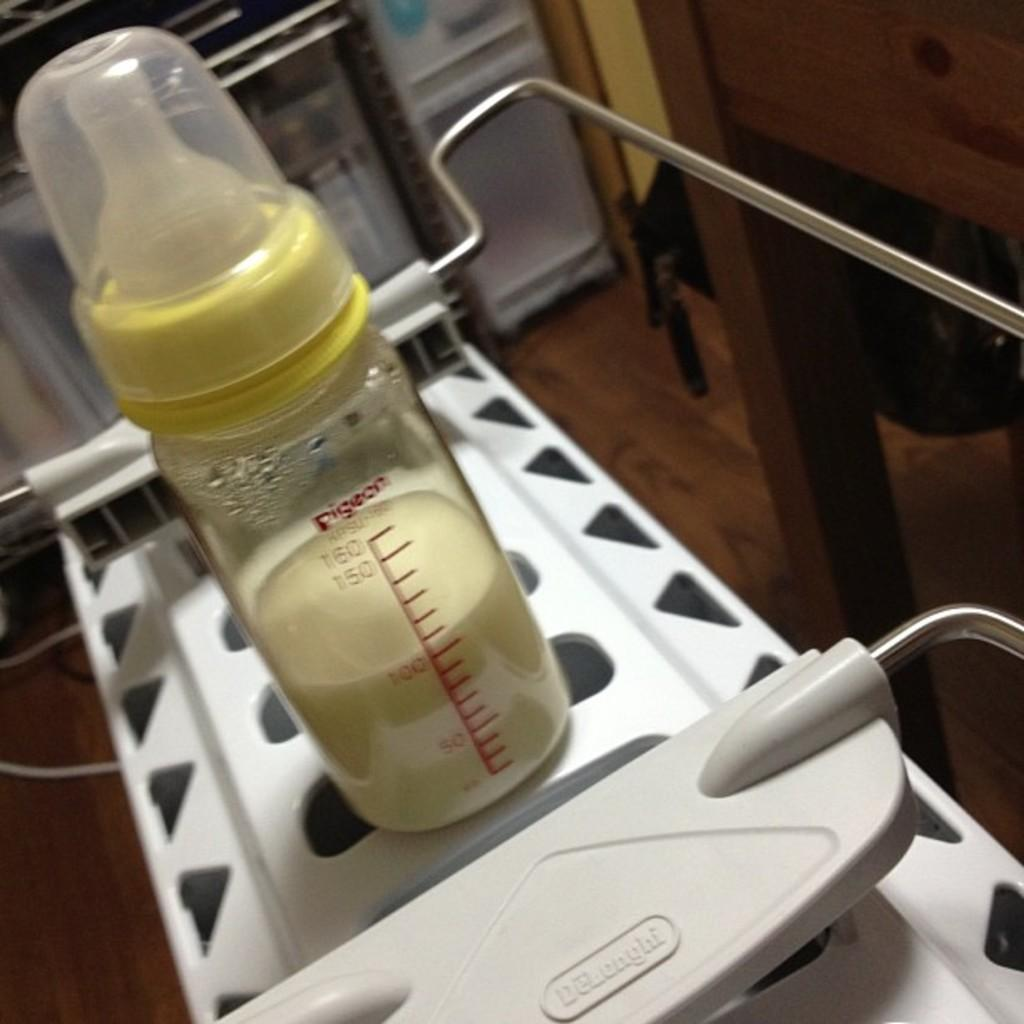What is the main object in the image? There is a milk bottle in the image. Reasoning: Let's think step by identifying the main subject in the image, which is the milk bottle. We then formulate a question that focuses on the location and characteristics of this subject, ensuring that each question can be answered definitively with the information given. We avoid yes/no questions and ensure that the language is simple and clear. Absurd Question/Answer: What type of mask is the milk bottle wearing in the image? There is no mask present in the image, as the image only features a milk bottle. 